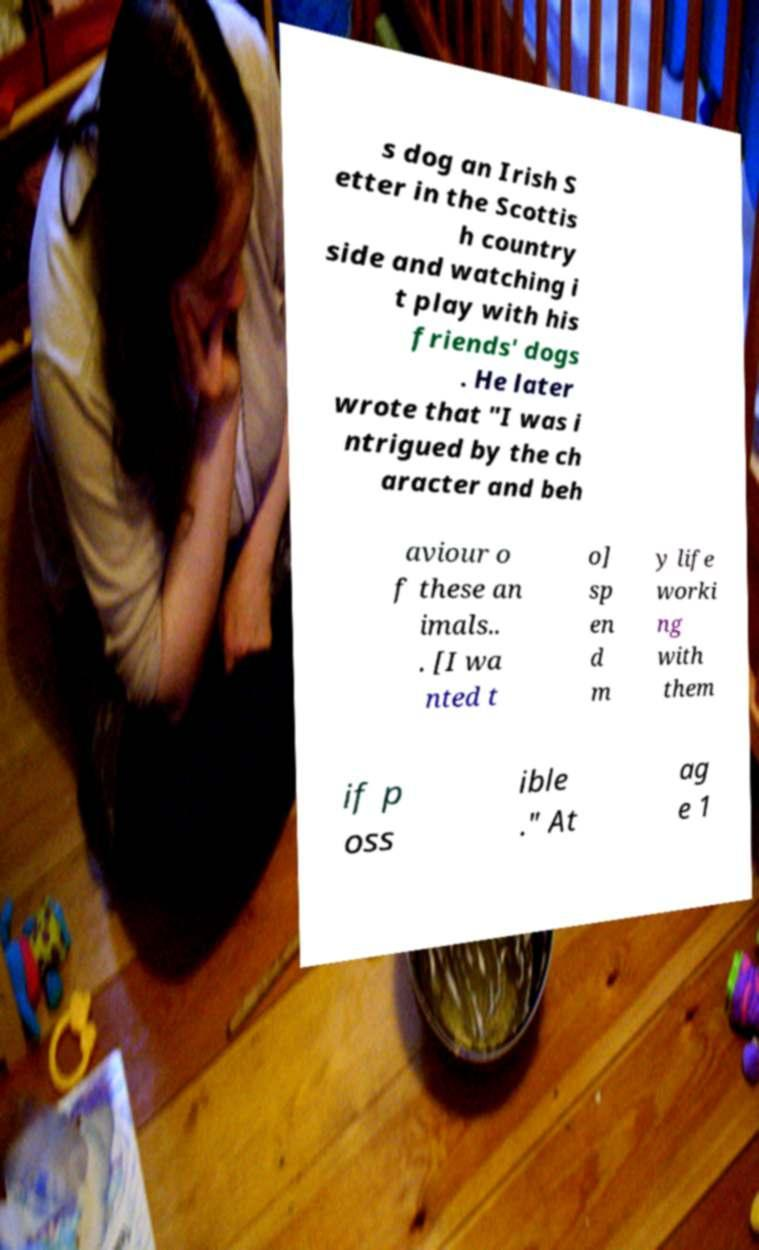Could you extract and type out the text from this image? s dog an Irish S etter in the Scottis h country side and watching i t play with his friends' dogs . He later wrote that "I was i ntrigued by the ch aracter and beh aviour o f these an imals.. . [I wa nted t o] sp en d m y life worki ng with them if p oss ible ." At ag e 1 